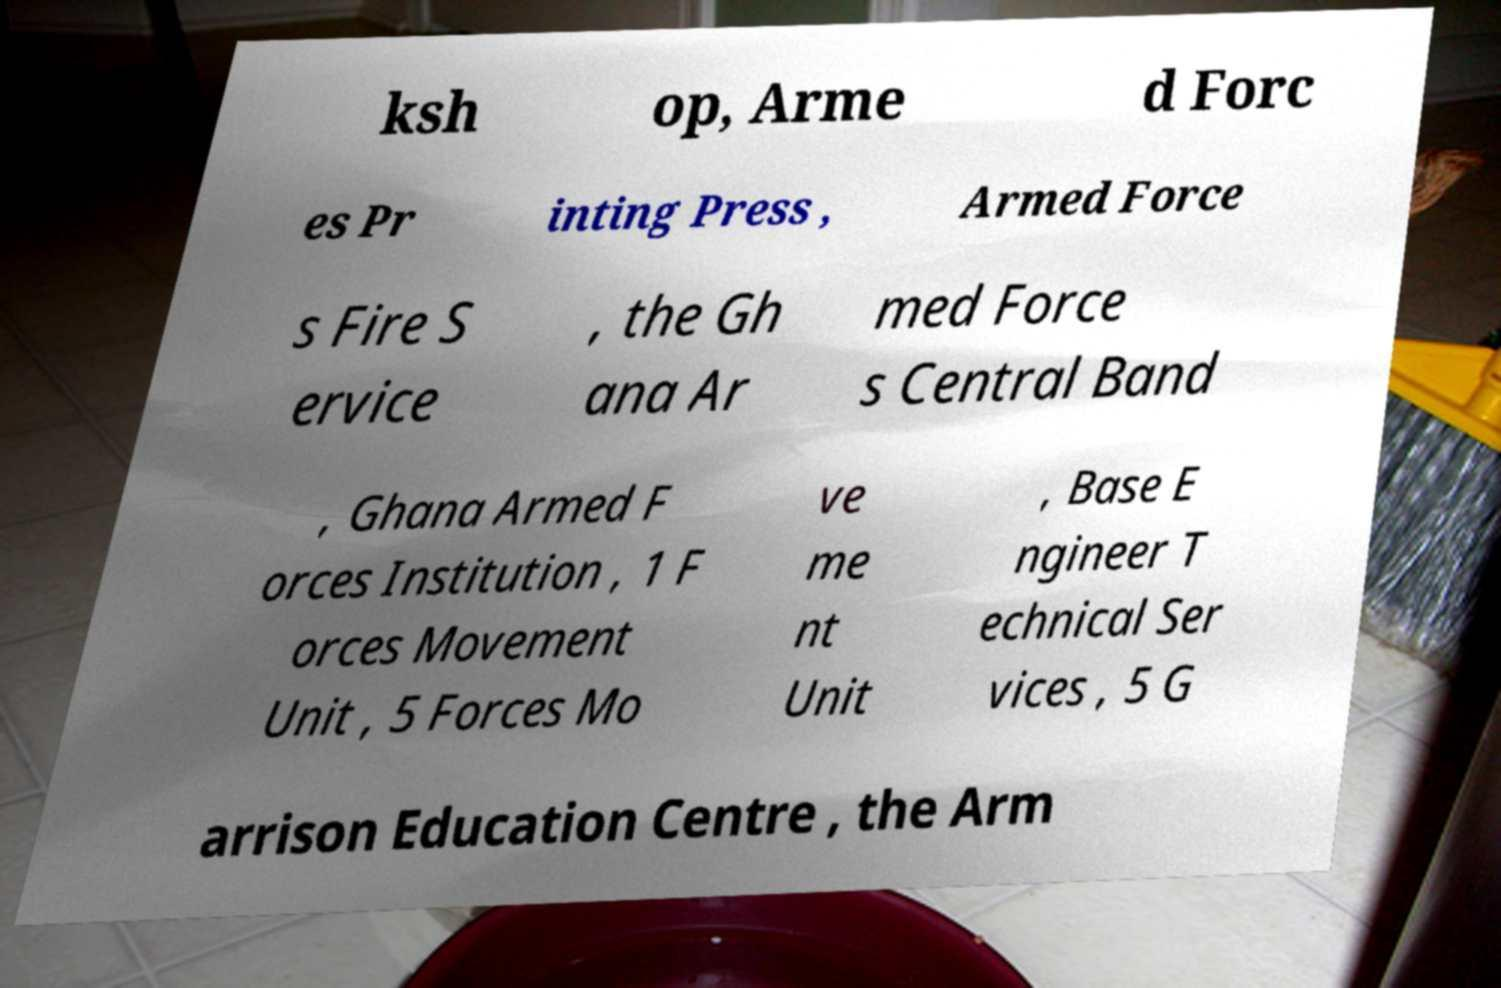I need the written content from this picture converted into text. Can you do that? ksh op, Arme d Forc es Pr inting Press , Armed Force s Fire S ervice , the Gh ana Ar med Force s Central Band , Ghana Armed F orces Institution , 1 F orces Movement Unit , 5 Forces Mo ve me nt Unit , Base E ngineer T echnical Ser vices , 5 G arrison Education Centre , the Arm 